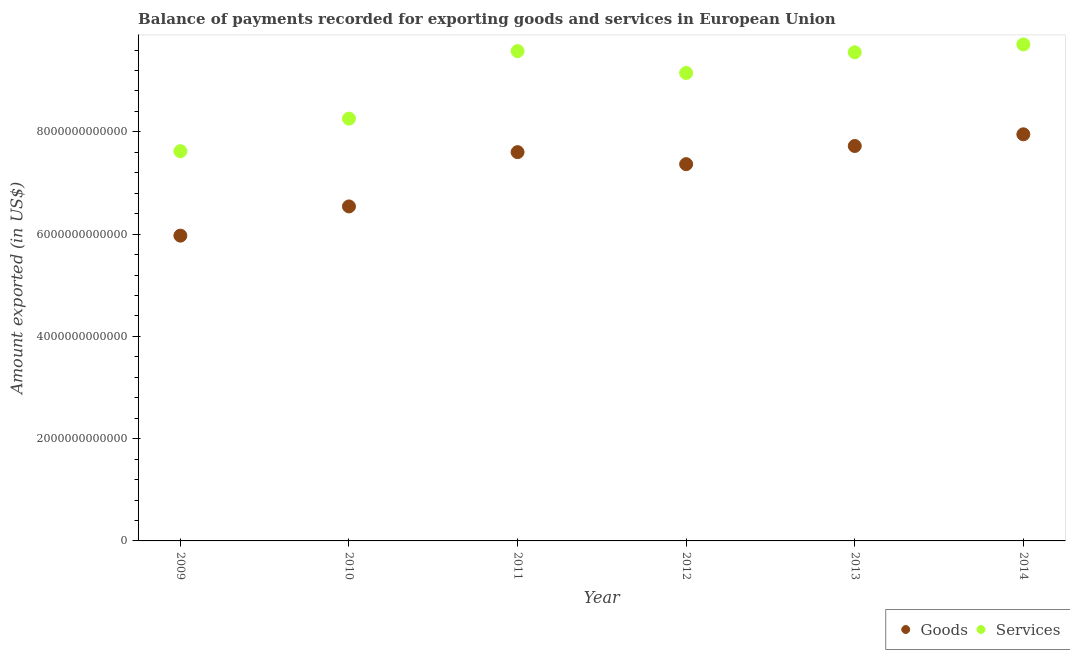What is the amount of services exported in 2014?
Provide a short and direct response. 9.71e+12. Across all years, what is the maximum amount of services exported?
Keep it short and to the point. 9.71e+12. Across all years, what is the minimum amount of goods exported?
Offer a very short reply. 5.97e+12. In which year was the amount of services exported maximum?
Your response must be concise. 2014. In which year was the amount of goods exported minimum?
Ensure brevity in your answer.  2009. What is the total amount of goods exported in the graph?
Provide a succinct answer. 4.32e+13. What is the difference between the amount of services exported in 2009 and that in 2013?
Offer a terse response. -1.93e+12. What is the difference between the amount of goods exported in 2011 and the amount of services exported in 2010?
Give a very brief answer. -6.55e+11. What is the average amount of goods exported per year?
Your response must be concise. 7.19e+12. In the year 2009, what is the difference between the amount of services exported and amount of goods exported?
Make the answer very short. 1.65e+12. In how many years, is the amount of services exported greater than 2400000000000 US$?
Make the answer very short. 6. What is the ratio of the amount of goods exported in 2010 to that in 2012?
Offer a very short reply. 0.89. What is the difference between the highest and the second highest amount of goods exported?
Your response must be concise. 2.28e+11. What is the difference between the highest and the lowest amount of services exported?
Offer a terse response. 2.09e+12. In how many years, is the amount of services exported greater than the average amount of services exported taken over all years?
Provide a succinct answer. 4. Is the amount of services exported strictly greater than the amount of goods exported over the years?
Your response must be concise. Yes. How many years are there in the graph?
Offer a very short reply. 6. What is the difference between two consecutive major ticks on the Y-axis?
Keep it short and to the point. 2.00e+12. Does the graph contain grids?
Provide a succinct answer. No. Where does the legend appear in the graph?
Your answer should be very brief. Bottom right. What is the title of the graph?
Ensure brevity in your answer.  Balance of payments recorded for exporting goods and services in European Union. Does "Domestic Liabilities" appear as one of the legend labels in the graph?
Provide a short and direct response. No. What is the label or title of the Y-axis?
Your answer should be very brief. Amount exported (in US$). What is the Amount exported (in US$) in Goods in 2009?
Offer a very short reply. 5.97e+12. What is the Amount exported (in US$) in Services in 2009?
Your response must be concise. 7.62e+12. What is the Amount exported (in US$) of Goods in 2010?
Your answer should be very brief. 6.54e+12. What is the Amount exported (in US$) in Services in 2010?
Your response must be concise. 8.26e+12. What is the Amount exported (in US$) of Goods in 2011?
Offer a terse response. 7.60e+12. What is the Amount exported (in US$) in Services in 2011?
Offer a very short reply. 9.58e+12. What is the Amount exported (in US$) of Goods in 2012?
Ensure brevity in your answer.  7.37e+12. What is the Amount exported (in US$) of Services in 2012?
Give a very brief answer. 9.15e+12. What is the Amount exported (in US$) in Goods in 2013?
Make the answer very short. 7.72e+12. What is the Amount exported (in US$) of Services in 2013?
Offer a very short reply. 9.56e+12. What is the Amount exported (in US$) in Goods in 2014?
Provide a succinct answer. 7.95e+12. What is the Amount exported (in US$) in Services in 2014?
Your response must be concise. 9.71e+12. Across all years, what is the maximum Amount exported (in US$) in Goods?
Ensure brevity in your answer.  7.95e+12. Across all years, what is the maximum Amount exported (in US$) of Services?
Ensure brevity in your answer.  9.71e+12. Across all years, what is the minimum Amount exported (in US$) in Goods?
Offer a very short reply. 5.97e+12. Across all years, what is the minimum Amount exported (in US$) in Services?
Provide a succinct answer. 7.62e+12. What is the total Amount exported (in US$) in Goods in the graph?
Your answer should be compact. 4.32e+13. What is the total Amount exported (in US$) in Services in the graph?
Provide a succinct answer. 5.39e+13. What is the difference between the Amount exported (in US$) of Goods in 2009 and that in 2010?
Make the answer very short. -5.71e+11. What is the difference between the Amount exported (in US$) of Services in 2009 and that in 2010?
Your answer should be compact. -6.37e+11. What is the difference between the Amount exported (in US$) in Goods in 2009 and that in 2011?
Your answer should be very brief. -1.63e+12. What is the difference between the Amount exported (in US$) of Services in 2009 and that in 2011?
Provide a short and direct response. -1.96e+12. What is the difference between the Amount exported (in US$) of Goods in 2009 and that in 2012?
Offer a very short reply. -1.40e+12. What is the difference between the Amount exported (in US$) in Services in 2009 and that in 2012?
Make the answer very short. -1.53e+12. What is the difference between the Amount exported (in US$) in Goods in 2009 and that in 2013?
Give a very brief answer. -1.75e+12. What is the difference between the Amount exported (in US$) in Services in 2009 and that in 2013?
Offer a terse response. -1.93e+12. What is the difference between the Amount exported (in US$) in Goods in 2009 and that in 2014?
Your answer should be compact. -1.98e+12. What is the difference between the Amount exported (in US$) of Services in 2009 and that in 2014?
Your answer should be very brief. -2.09e+12. What is the difference between the Amount exported (in US$) of Goods in 2010 and that in 2011?
Provide a short and direct response. -1.06e+12. What is the difference between the Amount exported (in US$) in Services in 2010 and that in 2011?
Make the answer very short. -1.32e+12. What is the difference between the Amount exported (in US$) of Goods in 2010 and that in 2012?
Provide a short and direct response. -8.27e+11. What is the difference between the Amount exported (in US$) in Services in 2010 and that in 2012?
Provide a succinct answer. -8.93e+11. What is the difference between the Amount exported (in US$) of Goods in 2010 and that in 2013?
Your answer should be very brief. -1.18e+12. What is the difference between the Amount exported (in US$) in Services in 2010 and that in 2013?
Give a very brief answer. -1.30e+12. What is the difference between the Amount exported (in US$) of Goods in 2010 and that in 2014?
Offer a very short reply. -1.41e+12. What is the difference between the Amount exported (in US$) in Services in 2010 and that in 2014?
Make the answer very short. -1.45e+12. What is the difference between the Amount exported (in US$) of Goods in 2011 and that in 2012?
Your response must be concise. 2.35e+11. What is the difference between the Amount exported (in US$) in Services in 2011 and that in 2012?
Provide a succinct answer. 4.28e+11. What is the difference between the Amount exported (in US$) of Goods in 2011 and that in 2013?
Ensure brevity in your answer.  -1.20e+11. What is the difference between the Amount exported (in US$) in Services in 2011 and that in 2013?
Offer a very short reply. 2.33e+1. What is the difference between the Amount exported (in US$) in Goods in 2011 and that in 2014?
Offer a very short reply. -3.49e+11. What is the difference between the Amount exported (in US$) in Services in 2011 and that in 2014?
Provide a succinct answer. -1.30e+11. What is the difference between the Amount exported (in US$) of Goods in 2012 and that in 2013?
Provide a succinct answer. -3.55e+11. What is the difference between the Amount exported (in US$) of Services in 2012 and that in 2013?
Give a very brief answer. -4.04e+11. What is the difference between the Amount exported (in US$) in Goods in 2012 and that in 2014?
Provide a succinct answer. -5.84e+11. What is the difference between the Amount exported (in US$) in Services in 2012 and that in 2014?
Offer a very short reply. -5.58e+11. What is the difference between the Amount exported (in US$) in Goods in 2013 and that in 2014?
Your response must be concise. -2.28e+11. What is the difference between the Amount exported (in US$) of Services in 2013 and that in 2014?
Provide a succinct answer. -1.54e+11. What is the difference between the Amount exported (in US$) of Goods in 2009 and the Amount exported (in US$) of Services in 2010?
Provide a short and direct response. -2.29e+12. What is the difference between the Amount exported (in US$) in Goods in 2009 and the Amount exported (in US$) in Services in 2011?
Offer a terse response. -3.61e+12. What is the difference between the Amount exported (in US$) in Goods in 2009 and the Amount exported (in US$) in Services in 2012?
Keep it short and to the point. -3.18e+12. What is the difference between the Amount exported (in US$) in Goods in 2009 and the Amount exported (in US$) in Services in 2013?
Your response must be concise. -3.59e+12. What is the difference between the Amount exported (in US$) in Goods in 2009 and the Amount exported (in US$) in Services in 2014?
Give a very brief answer. -3.74e+12. What is the difference between the Amount exported (in US$) of Goods in 2010 and the Amount exported (in US$) of Services in 2011?
Provide a succinct answer. -3.04e+12. What is the difference between the Amount exported (in US$) of Goods in 2010 and the Amount exported (in US$) of Services in 2012?
Your answer should be very brief. -2.61e+12. What is the difference between the Amount exported (in US$) in Goods in 2010 and the Amount exported (in US$) in Services in 2013?
Your answer should be compact. -3.01e+12. What is the difference between the Amount exported (in US$) of Goods in 2010 and the Amount exported (in US$) of Services in 2014?
Provide a short and direct response. -3.17e+12. What is the difference between the Amount exported (in US$) in Goods in 2011 and the Amount exported (in US$) in Services in 2012?
Your answer should be compact. -1.55e+12. What is the difference between the Amount exported (in US$) in Goods in 2011 and the Amount exported (in US$) in Services in 2013?
Offer a very short reply. -1.95e+12. What is the difference between the Amount exported (in US$) in Goods in 2011 and the Amount exported (in US$) in Services in 2014?
Give a very brief answer. -2.11e+12. What is the difference between the Amount exported (in US$) in Goods in 2012 and the Amount exported (in US$) in Services in 2013?
Ensure brevity in your answer.  -2.19e+12. What is the difference between the Amount exported (in US$) of Goods in 2012 and the Amount exported (in US$) of Services in 2014?
Offer a terse response. -2.34e+12. What is the difference between the Amount exported (in US$) in Goods in 2013 and the Amount exported (in US$) in Services in 2014?
Your response must be concise. -1.99e+12. What is the average Amount exported (in US$) of Goods per year?
Your answer should be very brief. 7.19e+12. What is the average Amount exported (in US$) of Services per year?
Your answer should be compact. 8.98e+12. In the year 2009, what is the difference between the Amount exported (in US$) of Goods and Amount exported (in US$) of Services?
Provide a succinct answer. -1.65e+12. In the year 2010, what is the difference between the Amount exported (in US$) of Goods and Amount exported (in US$) of Services?
Make the answer very short. -1.72e+12. In the year 2011, what is the difference between the Amount exported (in US$) of Goods and Amount exported (in US$) of Services?
Provide a short and direct response. -1.98e+12. In the year 2012, what is the difference between the Amount exported (in US$) of Goods and Amount exported (in US$) of Services?
Make the answer very short. -1.78e+12. In the year 2013, what is the difference between the Amount exported (in US$) in Goods and Amount exported (in US$) in Services?
Provide a succinct answer. -1.83e+12. In the year 2014, what is the difference between the Amount exported (in US$) in Goods and Amount exported (in US$) in Services?
Your response must be concise. -1.76e+12. What is the ratio of the Amount exported (in US$) in Goods in 2009 to that in 2010?
Provide a succinct answer. 0.91. What is the ratio of the Amount exported (in US$) in Services in 2009 to that in 2010?
Give a very brief answer. 0.92. What is the ratio of the Amount exported (in US$) in Goods in 2009 to that in 2011?
Offer a very short reply. 0.79. What is the ratio of the Amount exported (in US$) of Services in 2009 to that in 2011?
Your answer should be very brief. 0.8. What is the ratio of the Amount exported (in US$) of Goods in 2009 to that in 2012?
Make the answer very short. 0.81. What is the ratio of the Amount exported (in US$) in Services in 2009 to that in 2012?
Ensure brevity in your answer.  0.83. What is the ratio of the Amount exported (in US$) in Goods in 2009 to that in 2013?
Make the answer very short. 0.77. What is the ratio of the Amount exported (in US$) of Services in 2009 to that in 2013?
Your answer should be compact. 0.8. What is the ratio of the Amount exported (in US$) of Goods in 2009 to that in 2014?
Your answer should be very brief. 0.75. What is the ratio of the Amount exported (in US$) in Services in 2009 to that in 2014?
Your answer should be very brief. 0.79. What is the ratio of the Amount exported (in US$) of Goods in 2010 to that in 2011?
Make the answer very short. 0.86. What is the ratio of the Amount exported (in US$) in Services in 2010 to that in 2011?
Make the answer very short. 0.86. What is the ratio of the Amount exported (in US$) of Goods in 2010 to that in 2012?
Your response must be concise. 0.89. What is the ratio of the Amount exported (in US$) of Services in 2010 to that in 2012?
Ensure brevity in your answer.  0.9. What is the ratio of the Amount exported (in US$) of Goods in 2010 to that in 2013?
Ensure brevity in your answer.  0.85. What is the ratio of the Amount exported (in US$) of Services in 2010 to that in 2013?
Provide a succinct answer. 0.86. What is the ratio of the Amount exported (in US$) in Goods in 2010 to that in 2014?
Provide a succinct answer. 0.82. What is the ratio of the Amount exported (in US$) of Services in 2010 to that in 2014?
Provide a succinct answer. 0.85. What is the ratio of the Amount exported (in US$) of Goods in 2011 to that in 2012?
Your answer should be very brief. 1.03. What is the ratio of the Amount exported (in US$) of Services in 2011 to that in 2012?
Keep it short and to the point. 1.05. What is the ratio of the Amount exported (in US$) of Goods in 2011 to that in 2013?
Keep it short and to the point. 0.98. What is the ratio of the Amount exported (in US$) of Services in 2011 to that in 2013?
Offer a very short reply. 1. What is the ratio of the Amount exported (in US$) in Goods in 2011 to that in 2014?
Offer a very short reply. 0.96. What is the ratio of the Amount exported (in US$) of Services in 2011 to that in 2014?
Your response must be concise. 0.99. What is the ratio of the Amount exported (in US$) in Goods in 2012 to that in 2013?
Your answer should be very brief. 0.95. What is the ratio of the Amount exported (in US$) of Services in 2012 to that in 2013?
Give a very brief answer. 0.96. What is the ratio of the Amount exported (in US$) of Goods in 2012 to that in 2014?
Offer a terse response. 0.93. What is the ratio of the Amount exported (in US$) in Services in 2012 to that in 2014?
Your response must be concise. 0.94. What is the ratio of the Amount exported (in US$) of Goods in 2013 to that in 2014?
Give a very brief answer. 0.97. What is the ratio of the Amount exported (in US$) in Services in 2013 to that in 2014?
Offer a very short reply. 0.98. What is the difference between the highest and the second highest Amount exported (in US$) of Goods?
Your response must be concise. 2.28e+11. What is the difference between the highest and the second highest Amount exported (in US$) in Services?
Ensure brevity in your answer.  1.30e+11. What is the difference between the highest and the lowest Amount exported (in US$) in Goods?
Offer a very short reply. 1.98e+12. What is the difference between the highest and the lowest Amount exported (in US$) of Services?
Your response must be concise. 2.09e+12. 